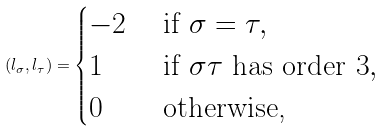Convert formula to latex. <formula><loc_0><loc_0><loc_500><loc_500>( l _ { \sigma } , l _ { \tau } ) = \begin{cases} - 2 & \text { if } \sigma = \tau , \\ 1 & \text { if } \sigma \tau \text { has order $3$} , \\ 0 & \text { otherwise,} \\ \end{cases}</formula> 